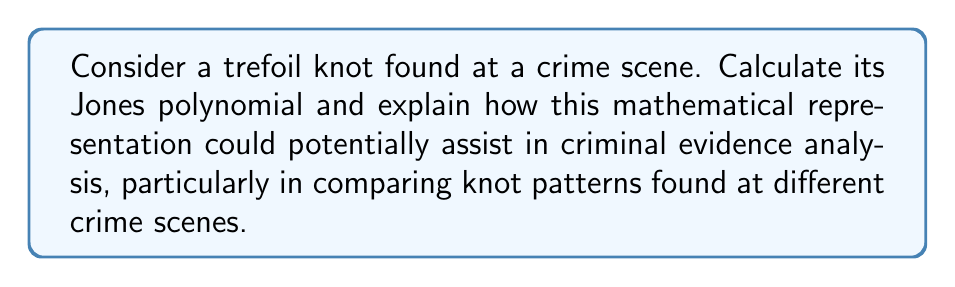Could you help me with this problem? To calculate the Jones polynomial of a trefoil knot and relate it to criminal evidence analysis, we'll follow these steps:

1) The trefoil knot is one of the simplest non-trivial knots. Its standard diagram has three crossings.

2) To calculate the Jones polynomial, we'll use the skein relation:

   $$t^{-1}V(L_+) - tV(L_-) = (t^{1/2} - t^{-1/2})V(L_0)$$

   Where $L_+$, $L_-$, and $L_0$ represent positive crossing, negative crossing, and no crossing respectively.

3) For the right-handed trefoil knot, all crossings are positive. We'll denote the unknot's Jones polynomial as $V(\bigcirc) = 1$.

4) Applying the skein relation three times:

   $$V(\text{trefoil}) = -t^4 + t^3 + t$$

5) This polynomial is a unique identifier for the trefoil knot.

6) In criminal evidence analysis, this could be used to:
   a) Compare knots found at different crime scenes mathematically.
   b) Distinguish between different types of knots used in crimes.
   c) Potentially link crimes based on the complexity and type of knots used.

7) For instance, if similar knots (with the same Jones polynomial) are found at multiple crime scenes, it might suggest a connection between the crimes or a signature of a particular perpetrator.

8) The Jones polynomial provides a more precise way to describe and compare knots than visual inspection alone, which could be crucial in building evidence in criminal cases.

9) However, it's important to note that while the Jones polynomial is a powerful tool, it's not a perfect discriminator. Some distinct knots can have the same Jones polynomial, so it should be used in conjunction with other forensic techniques.
Answer: $V(\text{trefoil}) = -t^4 + t^3 + t$ 